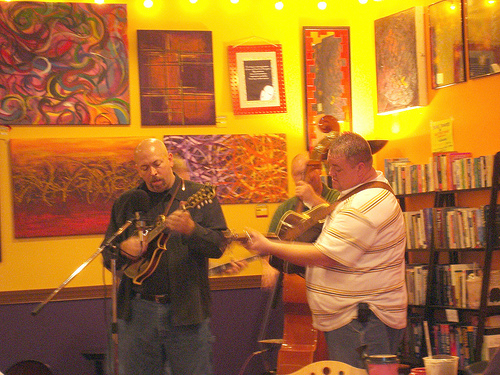<image>
Is the man in front of the painting? Yes. The man is positioned in front of the painting, appearing closer to the camera viewpoint. 